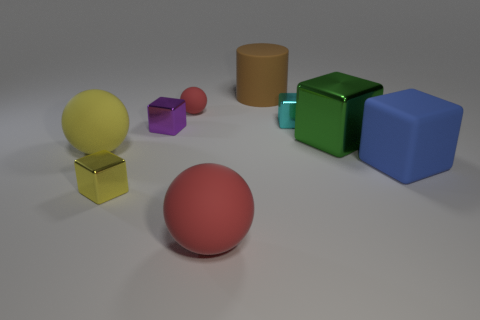Could you describe the different materials visible in the image? Certainly. The scene showcases objects with a variety of textures suggesting different materials. The reflective nature of some of the cubes indicates they are metallic, while others with a matte finish resemble solid plastic or perhaps a painted metal. The soft, subtle shadows each object casts add to the realism of their supposed materials. 